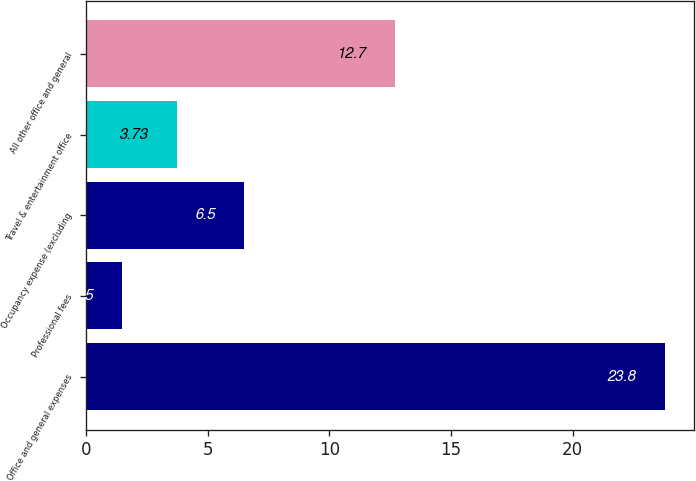<chart> <loc_0><loc_0><loc_500><loc_500><bar_chart><fcel>Office and general expenses<fcel>Professional fees<fcel>Occupancy expense (excluding<fcel>Travel & entertainment office<fcel>All other office and general<nl><fcel>23.8<fcel>1.5<fcel>6.5<fcel>3.73<fcel>12.7<nl></chart> 